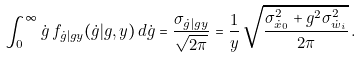<formula> <loc_0><loc_0><loc_500><loc_500>\int _ { 0 } ^ { \infty } \dot { g } \, f _ { \dot { g } | g y } ( \dot { g } | g , y ) \, d \dot { g } = \frac { \sigma _ { \dot { g } | g y } } { \sqrt { 2 \pi } } = \frac { 1 } { y } \, \sqrt { \frac { \sigma ^ { 2 } _ { \dot { x } _ { 0 } } + g ^ { 2 } \sigma ^ { 2 } _ { \dot { w } _ { i } } } { 2 \pi } } \, .</formula> 